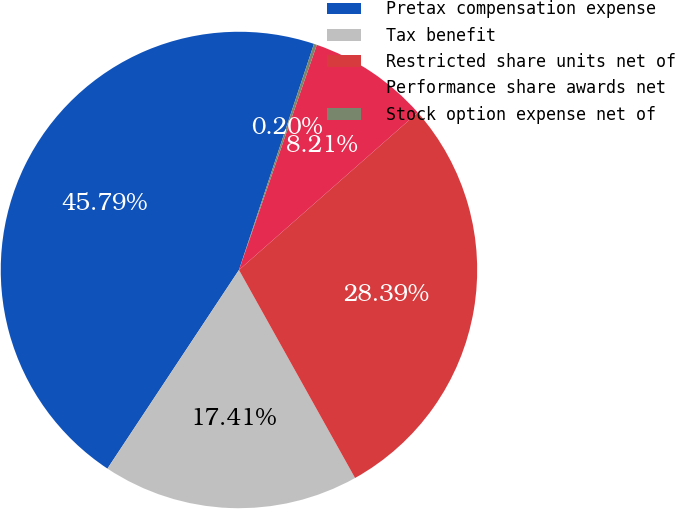<chart> <loc_0><loc_0><loc_500><loc_500><pie_chart><fcel>Pretax compensation expense<fcel>Tax benefit<fcel>Restricted share units net of<fcel>Performance share awards net<fcel>Stock option expense net of<nl><fcel>45.79%<fcel>17.41%<fcel>28.39%<fcel>8.21%<fcel>0.2%<nl></chart> 